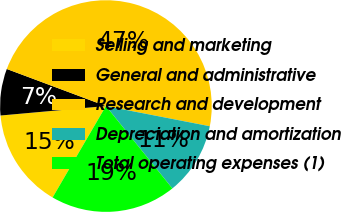<chart> <loc_0><loc_0><loc_500><loc_500><pie_chart><fcel>Selling and marketing<fcel>General and administrative<fcel>Research and development<fcel>Depreciation and amortization<fcel>Total operating expenses (1)<nl><fcel>15.17%<fcel>7.12%<fcel>47.36%<fcel>11.15%<fcel>19.2%<nl></chart> 